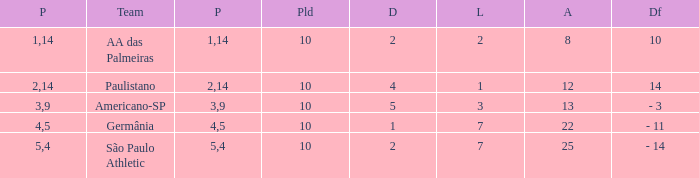What is the highest Drawn when the lost is 7 and the points are more than 4, and the against is less than 22? None. 